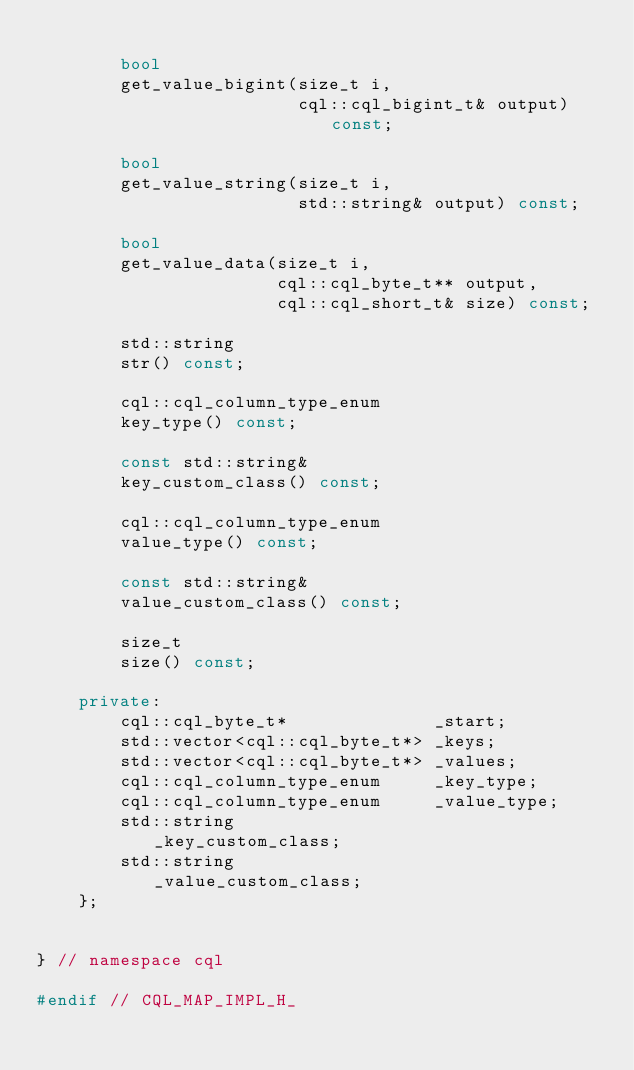<code> <loc_0><loc_0><loc_500><loc_500><_C++_>
        bool
        get_value_bigint(size_t i,
                         cql::cql_bigint_t& output) const;

        bool
        get_value_string(size_t i,
                         std::string& output) const;

        bool
        get_value_data(size_t i,
                       cql::cql_byte_t** output,
                       cql::cql_short_t& size) const;

        std::string
        str() const;

        cql::cql_column_type_enum
        key_type() const;

        const std::string&
        key_custom_class() const;

        cql::cql_column_type_enum
        value_type() const;

        const std::string&
        value_custom_class() const;

        size_t
        size() const;

    private:
        cql::cql_byte_t*              _start;
        std::vector<cql::cql_byte_t*> _keys;
        std::vector<cql::cql_byte_t*> _values;
        cql::cql_column_type_enum     _key_type;
        cql::cql_column_type_enum     _value_type;
        std::string                   _key_custom_class;
        std::string                   _value_custom_class;
    };


} // namespace cql

#endif // CQL_MAP_IMPL_H_
</code> 